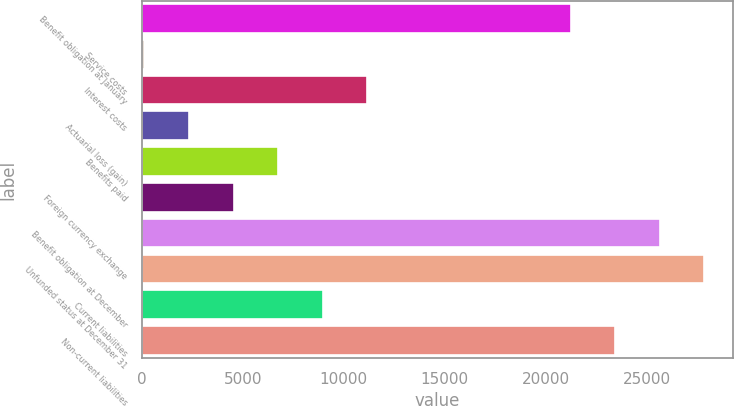<chart> <loc_0><loc_0><loc_500><loc_500><bar_chart><fcel>Benefit obligation at January<fcel>Service costs<fcel>Interest costs<fcel>Actuarial loss (gain)<fcel>Benefits paid<fcel>Foreign currency exchange<fcel>Benefit obligation at December<fcel>Unfunded status at December 31<fcel>Current liabilities<fcel>Non-current liabilities<nl><fcel>21237<fcel>125<fcel>11172.5<fcel>2334.5<fcel>6753.5<fcel>4544<fcel>25656<fcel>27865.5<fcel>8963<fcel>23446.5<nl></chart> 